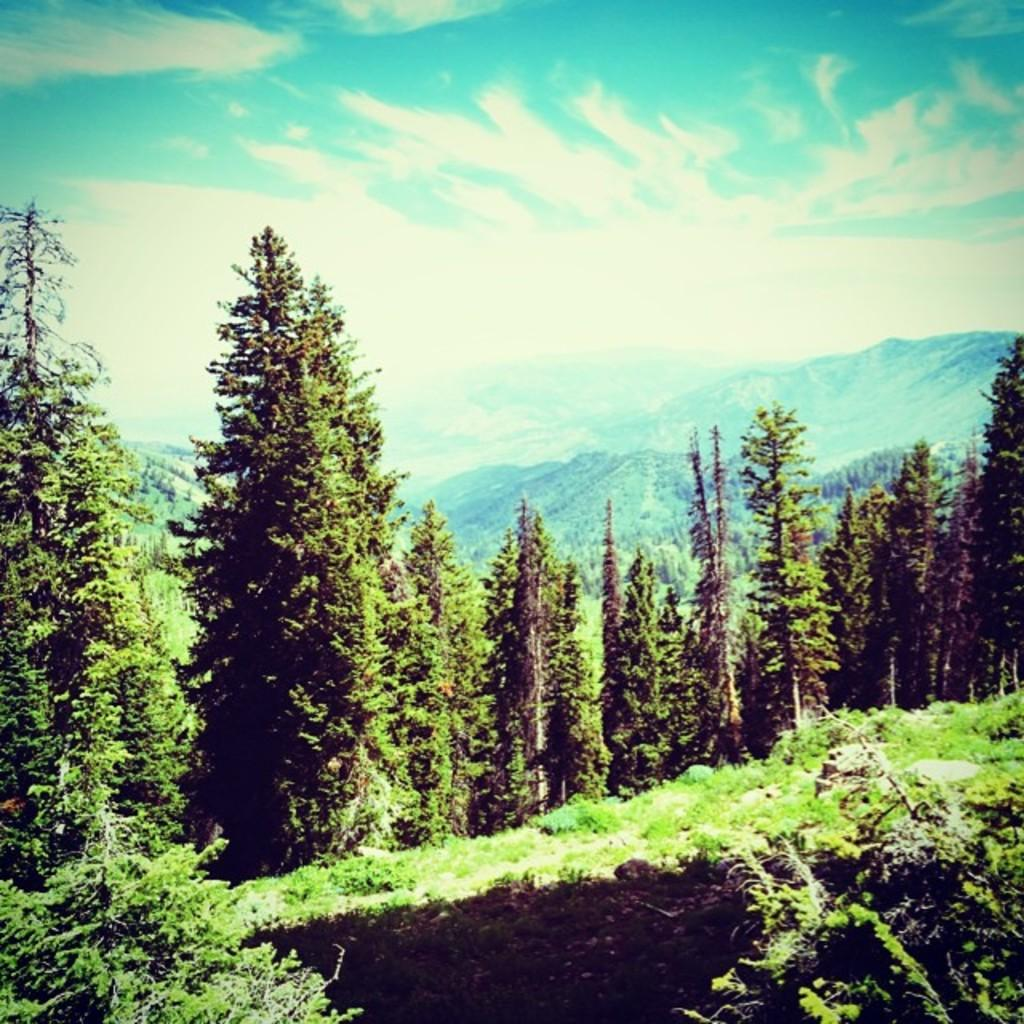What natural element is visible in the image? The sky is visible in the image. What can be seen in the sky in the image? Clouds are present in the image. What type of vegetation is visible in the image? Trees and plants are visible in the image. What type of terrain is present in the image? Hills are present in the image. What type of ground cover is visible in the image? Grass is visible in the image. What type of fruit is hanging from the trees in the image? There is no fruit present in the image. 